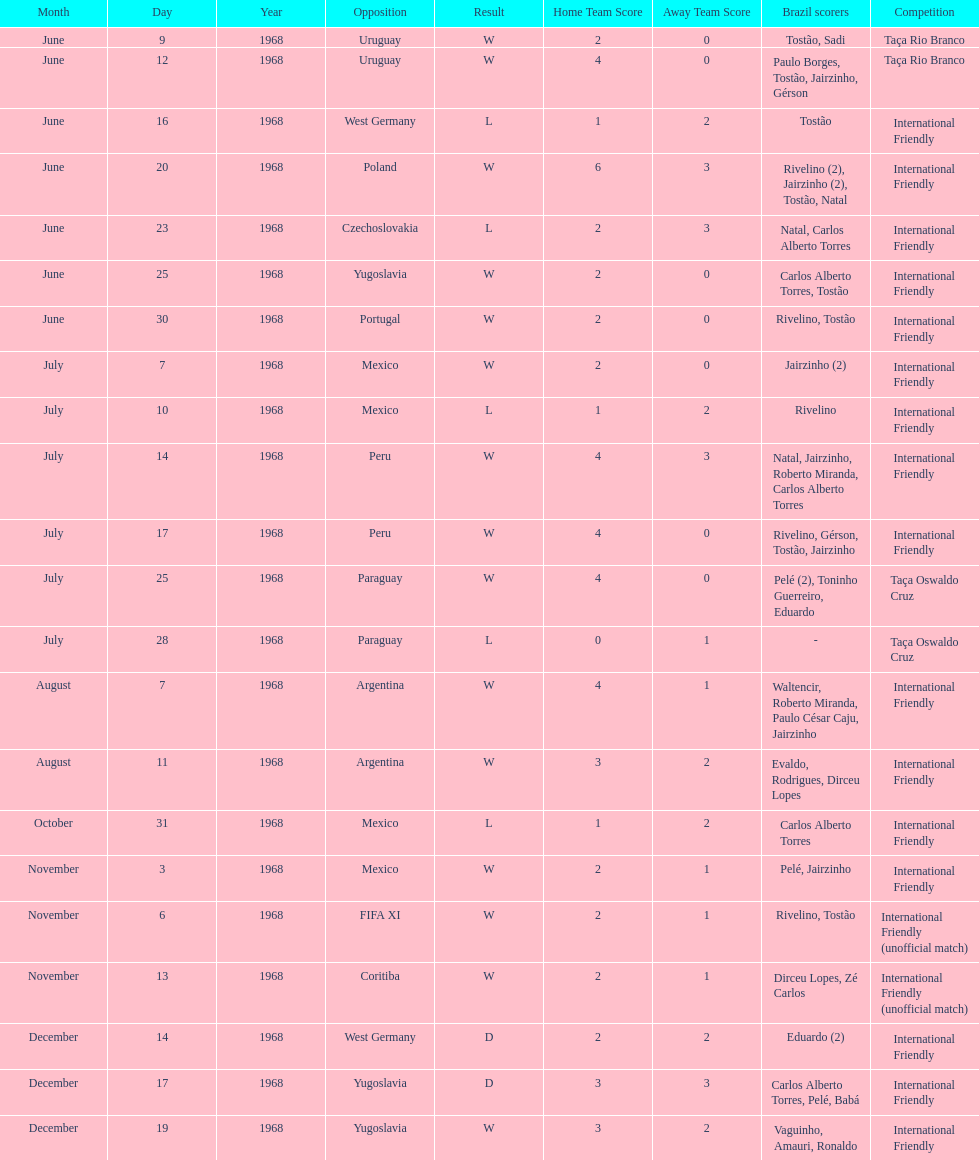Parse the full table. {'header': ['Month', 'Day', 'Year', 'Opposition', 'Result', 'Home Team Score', 'Away Team Score', 'Brazil scorers', 'Competition'], 'rows': [['June', '9', '1968', 'Uruguay', 'W', '2', '0', 'Tostão, Sadi', 'Taça Rio Branco'], ['June', '12', '1968', 'Uruguay', 'W', '4', '0', 'Paulo Borges, Tostão, Jairzinho, Gérson', 'Taça Rio Branco'], ['June', '16', '1968', 'West Germany', 'L', '1', '2', 'Tostão', 'International Friendly'], ['June', '20', '1968', 'Poland', 'W', '6', '3', 'Rivelino (2), Jairzinho (2), Tostão, Natal', 'International Friendly'], ['June', '23', '1968', 'Czechoslovakia', 'L', '2', '3', 'Natal, Carlos Alberto Torres', 'International Friendly'], ['June', '25', '1968', 'Yugoslavia', 'W', '2', '0', 'Carlos Alberto Torres, Tostão', 'International Friendly'], ['June', '30', '1968', 'Portugal', 'W', '2', '0', 'Rivelino, Tostão', 'International Friendly'], ['July', '7', '1968', 'Mexico', 'W', '2', '0', 'Jairzinho (2)', 'International Friendly'], ['July', '10', '1968', 'Mexico', 'L', '1', '2', 'Rivelino', 'International Friendly'], ['July', '14', '1968', 'Peru', 'W', '4', '3', 'Natal, Jairzinho, Roberto Miranda, Carlos Alberto Torres', 'International Friendly'], ['July', '17', '1968', 'Peru', 'W', '4', '0', 'Rivelino, Gérson, Tostão, Jairzinho', 'International Friendly'], ['July', '25', '1968', 'Paraguay', 'W', '4', '0', 'Pelé (2), Toninho Guerreiro, Eduardo', 'Taça Oswaldo Cruz'], ['July', '28', '1968', 'Paraguay', 'L', '0', '1', '-', 'Taça Oswaldo Cruz'], ['August', '7', '1968', 'Argentina', 'W', '4', '1', 'Waltencir, Roberto Miranda, Paulo César Caju, Jairzinho', 'International Friendly'], ['August', '11', '1968', 'Argentina', 'W', '3', '2', 'Evaldo, Rodrigues, Dirceu Lopes', 'International Friendly'], ['October', '31', '1968', 'Mexico', 'L', '1', '2', 'Carlos Alberto Torres', 'International Friendly'], ['November', '3', '1968', 'Mexico', 'W', '2', '1', 'Pelé, Jairzinho', 'International Friendly'], ['November', '6', '1968', 'FIFA XI', 'W', '2', '1', 'Rivelino, Tostão', 'International Friendly (unofficial match)'], ['November', '13', '1968', 'Coritiba', 'W', '2', '1', 'Dirceu Lopes, Zé Carlos', 'International Friendly (unofficial match)'], ['December', '14', '1968', 'West Germany', 'D', '2', '2', 'Eduardo (2)', 'International Friendly'], ['December', '17', '1968', 'Yugoslavia', 'D', '3', '3', 'Carlos Alberto Torres, Pelé, Babá', 'International Friendly'], ['December', '19', '1968', 'Yugoslavia', 'W', '3', '2', 'Vaguinho, Amauri, Ronaldo', 'International Friendly']]} What is the number of countries they have played? 11. 